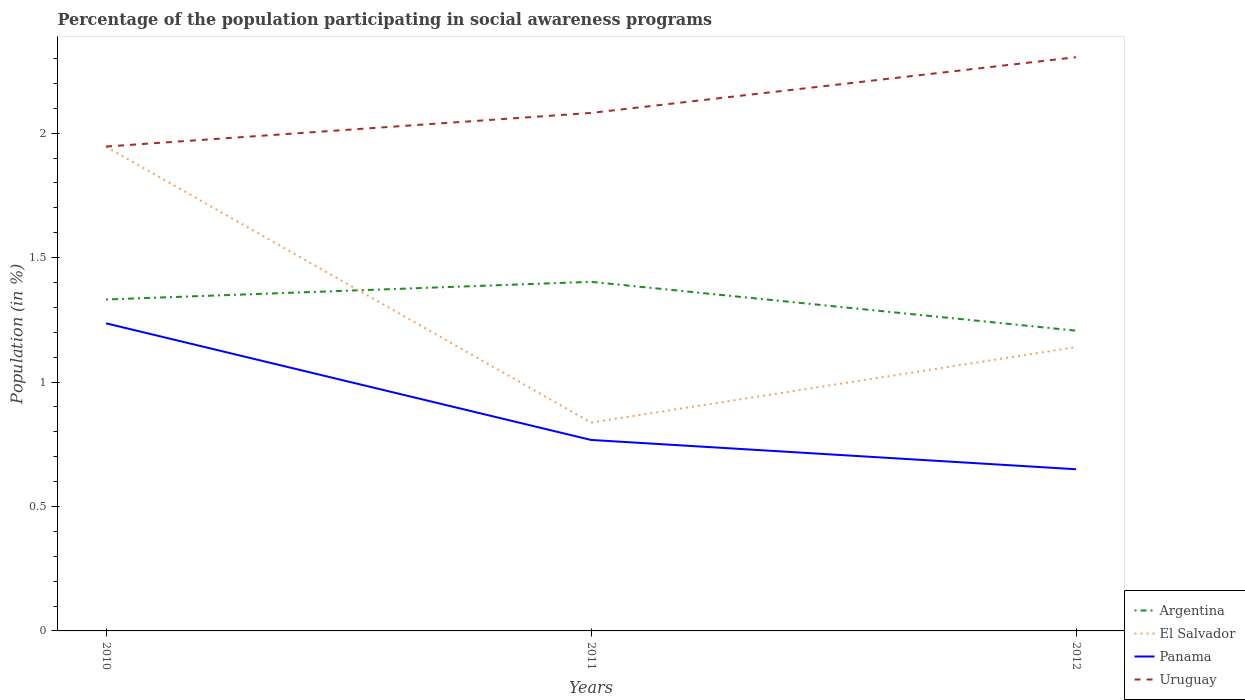Does the line corresponding to Argentina intersect with the line corresponding to El Salvador?
Provide a short and direct response. Yes. Is the number of lines equal to the number of legend labels?
Give a very brief answer. Yes. Across all years, what is the maximum percentage of the population participating in social awareness programs in Uruguay?
Provide a succinct answer. 1.95. What is the total percentage of the population participating in social awareness programs in Argentina in the graph?
Offer a terse response. -0.07. What is the difference between the highest and the second highest percentage of the population participating in social awareness programs in Panama?
Your answer should be very brief. 0.59. What is the difference between two consecutive major ticks on the Y-axis?
Give a very brief answer. 0.5. Are the values on the major ticks of Y-axis written in scientific E-notation?
Ensure brevity in your answer.  No. Does the graph contain any zero values?
Provide a succinct answer. No. How are the legend labels stacked?
Make the answer very short. Vertical. What is the title of the graph?
Ensure brevity in your answer.  Percentage of the population participating in social awareness programs. Does "Low income" appear as one of the legend labels in the graph?
Provide a short and direct response. No. What is the Population (in %) in Argentina in 2010?
Provide a succinct answer. 1.33. What is the Population (in %) in El Salvador in 2010?
Your response must be concise. 1.95. What is the Population (in %) in Panama in 2010?
Offer a terse response. 1.24. What is the Population (in %) of Uruguay in 2010?
Your answer should be very brief. 1.95. What is the Population (in %) in Argentina in 2011?
Provide a short and direct response. 1.4. What is the Population (in %) of El Salvador in 2011?
Your answer should be compact. 0.84. What is the Population (in %) in Panama in 2011?
Your response must be concise. 0.77. What is the Population (in %) of Uruguay in 2011?
Make the answer very short. 2.08. What is the Population (in %) in Argentina in 2012?
Your response must be concise. 1.21. What is the Population (in %) of El Salvador in 2012?
Provide a short and direct response. 1.14. What is the Population (in %) in Panama in 2012?
Make the answer very short. 0.65. What is the Population (in %) of Uruguay in 2012?
Keep it short and to the point. 2.31. Across all years, what is the maximum Population (in %) of Argentina?
Ensure brevity in your answer.  1.4. Across all years, what is the maximum Population (in %) of El Salvador?
Provide a short and direct response. 1.95. Across all years, what is the maximum Population (in %) of Panama?
Keep it short and to the point. 1.24. Across all years, what is the maximum Population (in %) of Uruguay?
Keep it short and to the point. 2.31. Across all years, what is the minimum Population (in %) in Argentina?
Offer a terse response. 1.21. Across all years, what is the minimum Population (in %) in El Salvador?
Your answer should be compact. 0.84. Across all years, what is the minimum Population (in %) of Panama?
Your answer should be very brief. 0.65. Across all years, what is the minimum Population (in %) of Uruguay?
Offer a very short reply. 1.95. What is the total Population (in %) in Argentina in the graph?
Provide a succinct answer. 3.94. What is the total Population (in %) of El Salvador in the graph?
Give a very brief answer. 3.92. What is the total Population (in %) in Panama in the graph?
Make the answer very short. 2.65. What is the total Population (in %) of Uruguay in the graph?
Provide a short and direct response. 6.33. What is the difference between the Population (in %) in Argentina in 2010 and that in 2011?
Offer a very short reply. -0.07. What is the difference between the Population (in %) in El Salvador in 2010 and that in 2011?
Offer a terse response. 1.11. What is the difference between the Population (in %) in Panama in 2010 and that in 2011?
Give a very brief answer. 0.47. What is the difference between the Population (in %) in Uruguay in 2010 and that in 2011?
Keep it short and to the point. -0.14. What is the difference between the Population (in %) of Argentina in 2010 and that in 2012?
Provide a short and direct response. 0.13. What is the difference between the Population (in %) in El Salvador in 2010 and that in 2012?
Your answer should be compact. 0.8. What is the difference between the Population (in %) of Panama in 2010 and that in 2012?
Provide a short and direct response. 0.59. What is the difference between the Population (in %) in Uruguay in 2010 and that in 2012?
Give a very brief answer. -0.36. What is the difference between the Population (in %) of Argentina in 2011 and that in 2012?
Provide a succinct answer. 0.2. What is the difference between the Population (in %) in El Salvador in 2011 and that in 2012?
Your response must be concise. -0.3. What is the difference between the Population (in %) of Panama in 2011 and that in 2012?
Your answer should be very brief. 0.12. What is the difference between the Population (in %) of Uruguay in 2011 and that in 2012?
Ensure brevity in your answer.  -0.22. What is the difference between the Population (in %) of Argentina in 2010 and the Population (in %) of El Salvador in 2011?
Make the answer very short. 0.49. What is the difference between the Population (in %) in Argentina in 2010 and the Population (in %) in Panama in 2011?
Your answer should be very brief. 0.56. What is the difference between the Population (in %) of Argentina in 2010 and the Population (in %) of Uruguay in 2011?
Provide a succinct answer. -0.75. What is the difference between the Population (in %) of El Salvador in 2010 and the Population (in %) of Panama in 2011?
Your answer should be very brief. 1.18. What is the difference between the Population (in %) in El Salvador in 2010 and the Population (in %) in Uruguay in 2011?
Your answer should be compact. -0.14. What is the difference between the Population (in %) of Panama in 2010 and the Population (in %) of Uruguay in 2011?
Offer a terse response. -0.85. What is the difference between the Population (in %) in Argentina in 2010 and the Population (in %) in El Salvador in 2012?
Offer a terse response. 0.19. What is the difference between the Population (in %) of Argentina in 2010 and the Population (in %) of Panama in 2012?
Provide a succinct answer. 0.68. What is the difference between the Population (in %) of Argentina in 2010 and the Population (in %) of Uruguay in 2012?
Your response must be concise. -0.97. What is the difference between the Population (in %) in El Salvador in 2010 and the Population (in %) in Panama in 2012?
Your answer should be compact. 1.3. What is the difference between the Population (in %) of El Salvador in 2010 and the Population (in %) of Uruguay in 2012?
Your answer should be compact. -0.36. What is the difference between the Population (in %) in Panama in 2010 and the Population (in %) in Uruguay in 2012?
Your answer should be compact. -1.07. What is the difference between the Population (in %) of Argentina in 2011 and the Population (in %) of El Salvador in 2012?
Offer a very short reply. 0.26. What is the difference between the Population (in %) of Argentina in 2011 and the Population (in %) of Panama in 2012?
Offer a very short reply. 0.75. What is the difference between the Population (in %) in Argentina in 2011 and the Population (in %) in Uruguay in 2012?
Your answer should be compact. -0.9. What is the difference between the Population (in %) in El Salvador in 2011 and the Population (in %) in Panama in 2012?
Your answer should be very brief. 0.19. What is the difference between the Population (in %) in El Salvador in 2011 and the Population (in %) in Uruguay in 2012?
Your answer should be very brief. -1.47. What is the difference between the Population (in %) in Panama in 2011 and the Population (in %) in Uruguay in 2012?
Offer a terse response. -1.54. What is the average Population (in %) in Argentina per year?
Make the answer very short. 1.31. What is the average Population (in %) of El Salvador per year?
Your response must be concise. 1.31. What is the average Population (in %) in Panama per year?
Provide a short and direct response. 0.88. What is the average Population (in %) of Uruguay per year?
Your response must be concise. 2.11. In the year 2010, what is the difference between the Population (in %) of Argentina and Population (in %) of El Salvador?
Offer a very short reply. -0.61. In the year 2010, what is the difference between the Population (in %) of Argentina and Population (in %) of Panama?
Ensure brevity in your answer.  0.1. In the year 2010, what is the difference between the Population (in %) of Argentina and Population (in %) of Uruguay?
Your response must be concise. -0.61. In the year 2010, what is the difference between the Population (in %) of El Salvador and Population (in %) of Panama?
Offer a very short reply. 0.71. In the year 2010, what is the difference between the Population (in %) in El Salvador and Population (in %) in Uruguay?
Offer a terse response. -0. In the year 2010, what is the difference between the Population (in %) of Panama and Population (in %) of Uruguay?
Offer a terse response. -0.71. In the year 2011, what is the difference between the Population (in %) in Argentina and Population (in %) in El Salvador?
Your answer should be compact. 0.57. In the year 2011, what is the difference between the Population (in %) in Argentina and Population (in %) in Panama?
Ensure brevity in your answer.  0.64. In the year 2011, what is the difference between the Population (in %) of Argentina and Population (in %) of Uruguay?
Keep it short and to the point. -0.68. In the year 2011, what is the difference between the Population (in %) in El Salvador and Population (in %) in Panama?
Give a very brief answer. 0.07. In the year 2011, what is the difference between the Population (in %) in El Salvador and Population (in %) in Uruguay?
Provide a short and direct response. -1.24. In the year 2011, what is the difference between the Population (in %) of Panama and Population (in %) of Uruguay?
Provide a succinct answer. -1.31. In the year 2012, what is the difference between the Population (in %) in Argentina and Population (in %) in El Salvador?
Ensure brevity in your answer.  0.07. In the year 2012, what is the difference between the Population (in %) of Argentina and Population (in %) of Panama?
Ensure brevity in your answer.  0.56. In the year 2012, what is the difference between the Population (in %) of Argentina and Population (in %) of Uruguay?
Your response must be concise. -1.1. In the year 2012, what is the difference between the Population (in %) in El Salvador and Population (in %) in Panama?
Make the answer very short. 0.49. In the year 2012, what is the difference between the Population (in %) of El Salvador and Population (in %) of Uruguay?
Provide a short and direct response. -1.16. In the year 2012, what is the difference between the Population (in %) of Panama and Population (in %) of Uruguay?
Keep it short and to the point. -1.66. What is the ratio of the Population (in %) in Argentina in 2010 to that in 2011?
Give a very brief answer. 0.95. What is the ratio of the Population (in %) in El Salvador in 2010 to that in 2011?
Your response must be concise. 2.32. What is the ratio of the Population (in %) of Panama in 2010 to that in 2011?
Offer a terse response. 1.61. What is the ratio of the Population (in %) in Uruguay in 2010 to that in 2011?
Ensure brevity in your answer.  0.94. What is the ratio of the Population (in %) in Argentina in 2010 to that in 2012?
Ensure brevity in your answer.  1.1. What is the ratio of the Population (in %) of El Salvador in 2010 to that in 2012?
Ensure brevity in your answer.  1.71. What is the ratio of the Population (in %) in Panama in 2010 to that in 2012?
Provide a short and direct response. 1.9. What is the ratio of the Population (in %) in Uruguay in 2010 to that in 2012?
Offer a very short reply. 0.84. What is the ratio of the Population (in %) of Argentina in 2011 to that in 2012?
Offer a terse response. 1.16. What is the ratio of the Population (in %) of El Salvador in 2011 to that in 2012?
Make the answer very short. 0.73. What is the ratio of the Population (in %) of Panama in 2011 to that in 2012?
Offer a very short reply. 1.18. What is the ratio of the Population (in %) of Uruguay in 2011 to that in 2012?
Offer a very short reply. 0.9. What is the difference between the highest and the second highest Population (in %) of Argentina?
Provide a succinct answer. 0.07. What is the difference between the highest and the second highest Population (in %) in El Salvador?
Ensure brevity in your answer.  0.8. What is the difference between the highest and the second highest Population (in %) in Panama?
Give a very brief answer. 0.47. What is the difference between the highest and the second highest Population (in %) of Uruguay?
Ensure brevity in your answer.  0.22. What is the difference between the highest and the lowest Population (in %) of Argentina?
Make the answer very short. 0.2. What is the difference between the highest and the lowest Population (in %) of El Salvador?
Your answer should be very brief. 1.11. What is the difference between the highest and the lowest Population (in %) of Panama?
Offer a very short reply. 0.59. What is the difference between the highest and the lowest Population (in %) in Uruguay?
Provide a succinct answer. 0.36. 